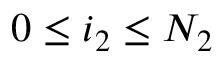<formula> <loc_0><loc_0><loc_500><loc_500>0 \leq i _ { 2 } \leq N _ { 2 }</formula> 